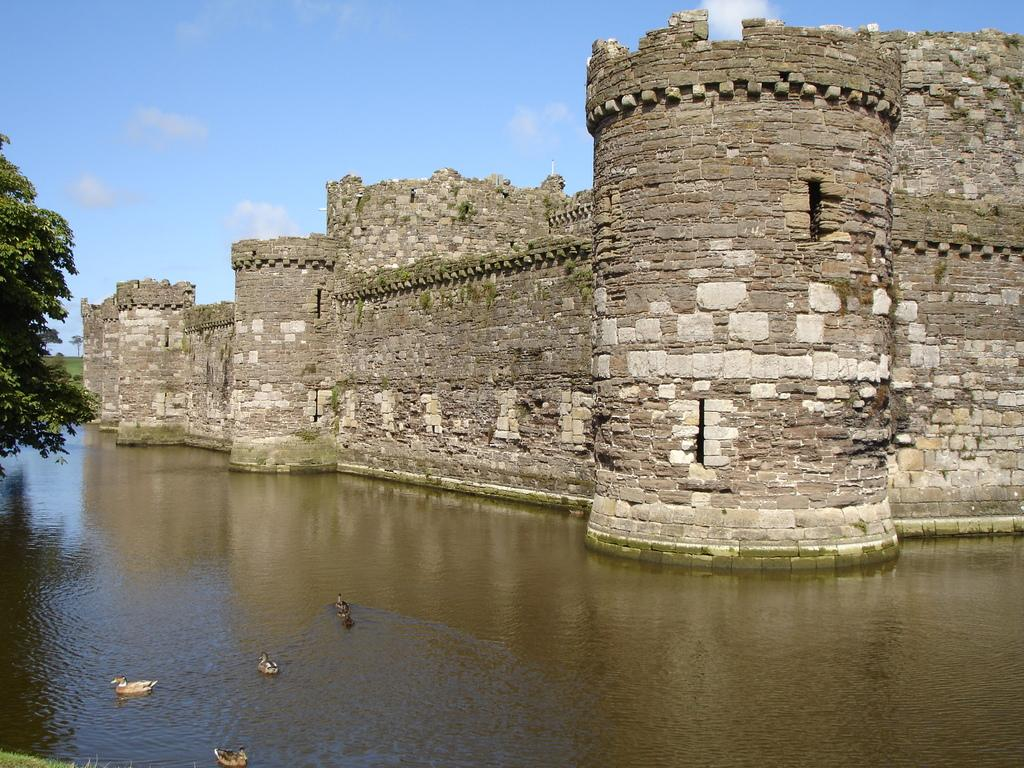What type of animals can be seen in the image? Birds can be seen in the image. What is the primary element in which the birds are situated? The birds are situated in water. What can be seen in the background of the image? There are trees in the image. What part of the natural environment is visible in the image? The sky and grass are visible in the image. What type of structure can be seen in the image? There is a fort in the image. What type of property does the snail own in the image? There is no snail present in the image, so it is not possible to determine what property it might own. 